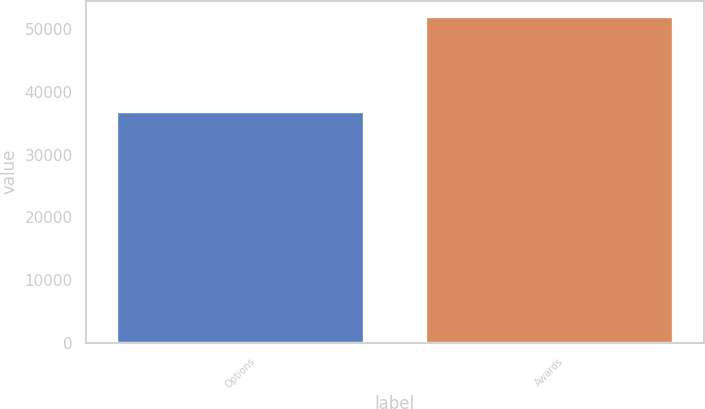Convert chart. <chart><loc_0><loc_0><loc_500><loc_500><bar_chart><fcel>Options<fcel>Awards<nl><fcel>36767<fcel>51951<nl></chart> 